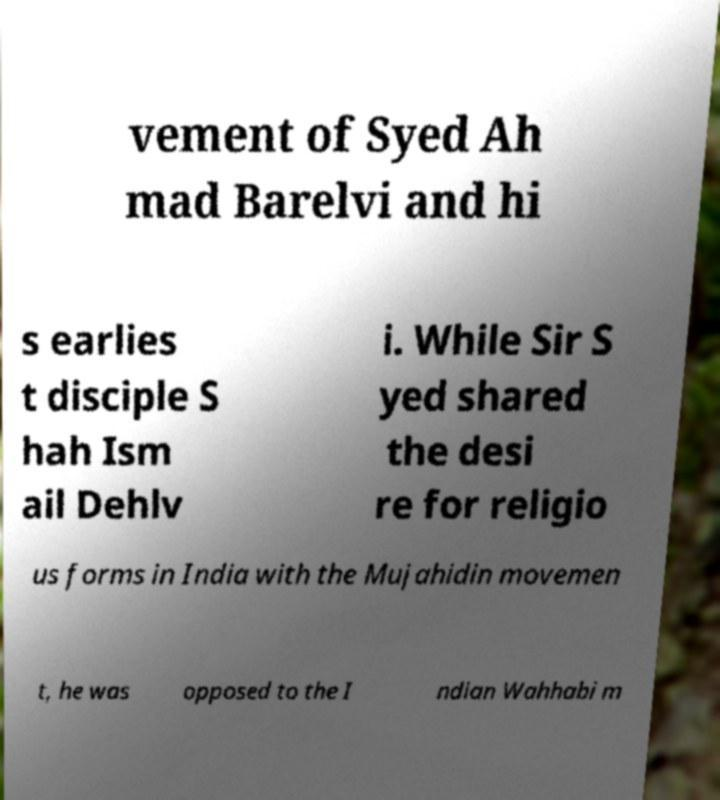Can you read and provide the text displayed in the image?This photo seems to have some interesting text. Can you extract and type it out for me? vement of Syed Ah mad Barelvi and hi s earlies t disciple S hah Ism ail Dehlv i. While Sir S yed shared the desi re for religio us forms in India with the Mujahidin movemen t, he was opposed to the I ndian Wahhabi m 